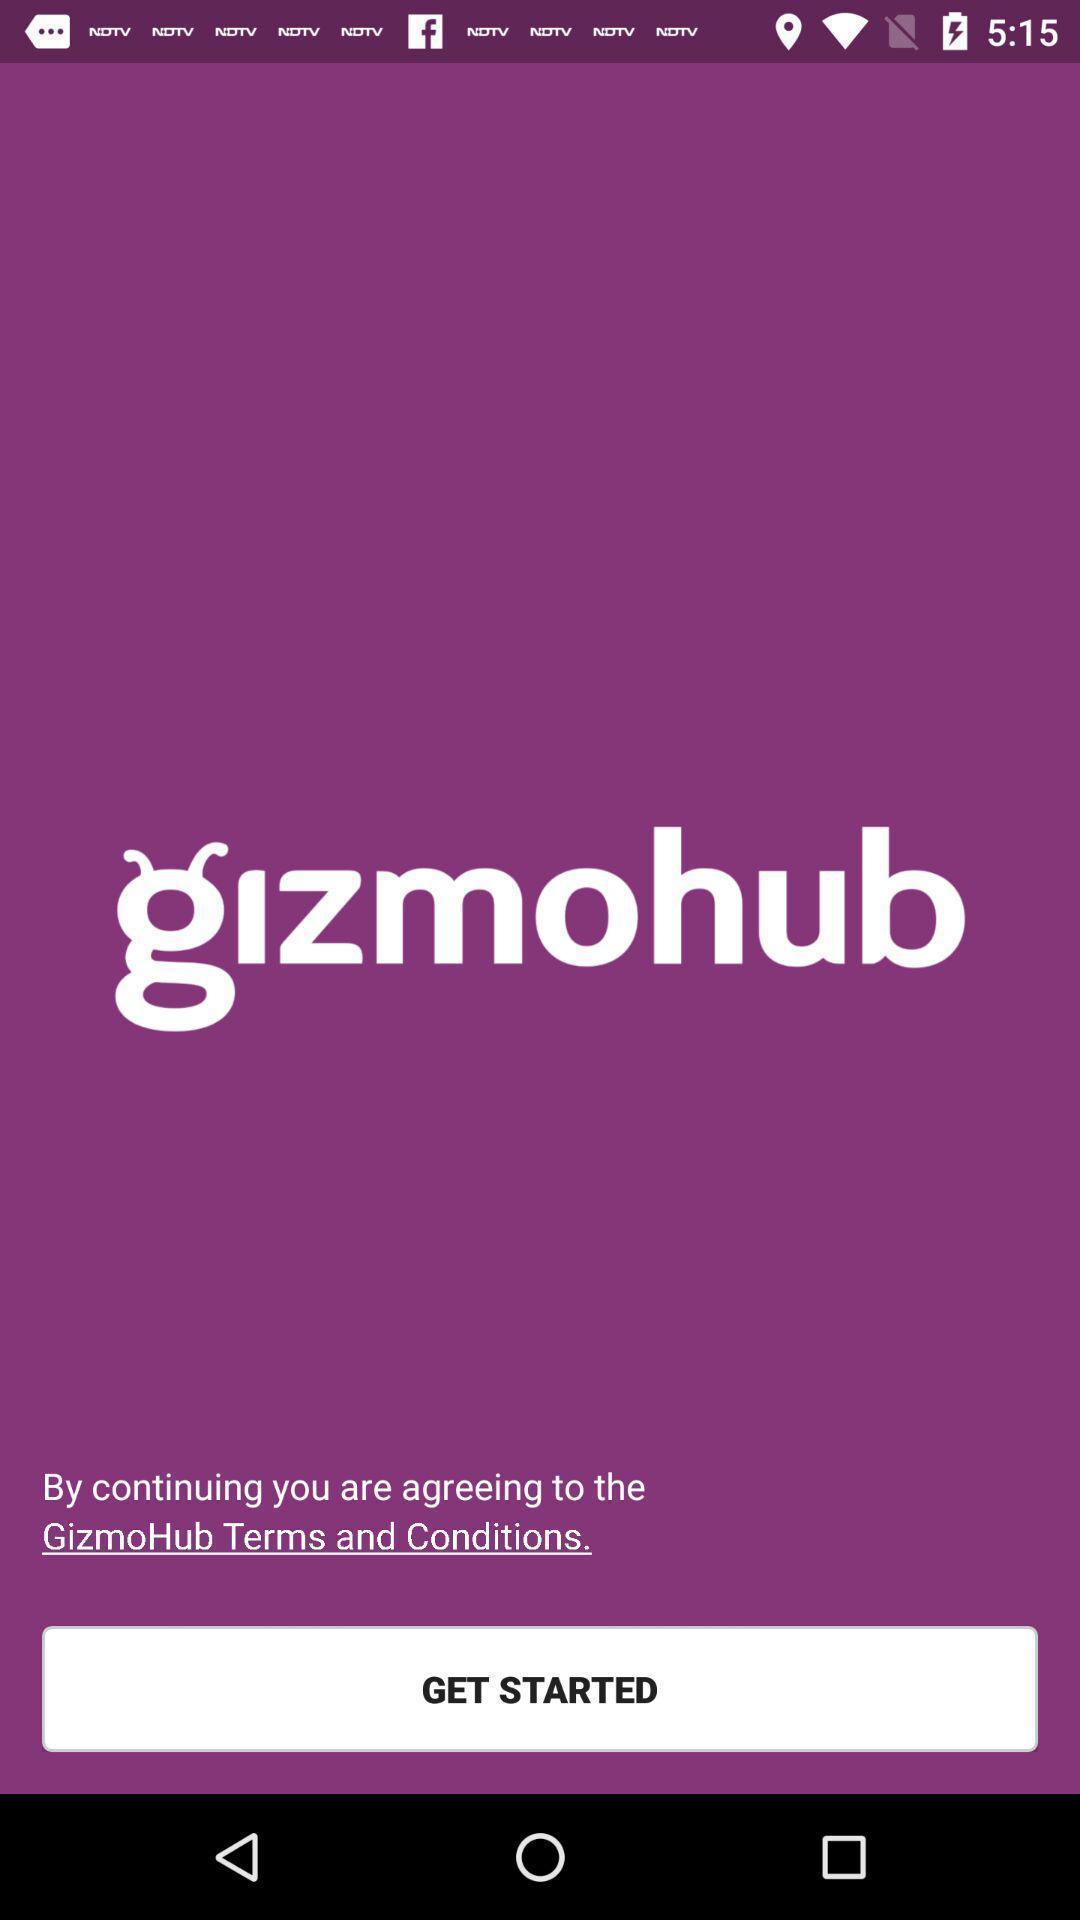Give me a narrative description of this picture. Welcome page of a gps locator app. 